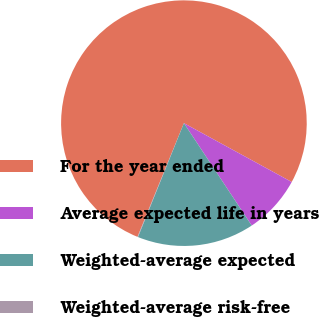<chart> <loc_0><loc_0><loc_500><loc_500><pie_chart><fcel>For the year ended<fcel>Average expected life in years<fcel>Weighted-average expected<fcel>Weighted-average risk-free<nl><fcel>76.78%<fcel>7.74%<fcel>15.41%<fcel>0.07%<nl></chart> 